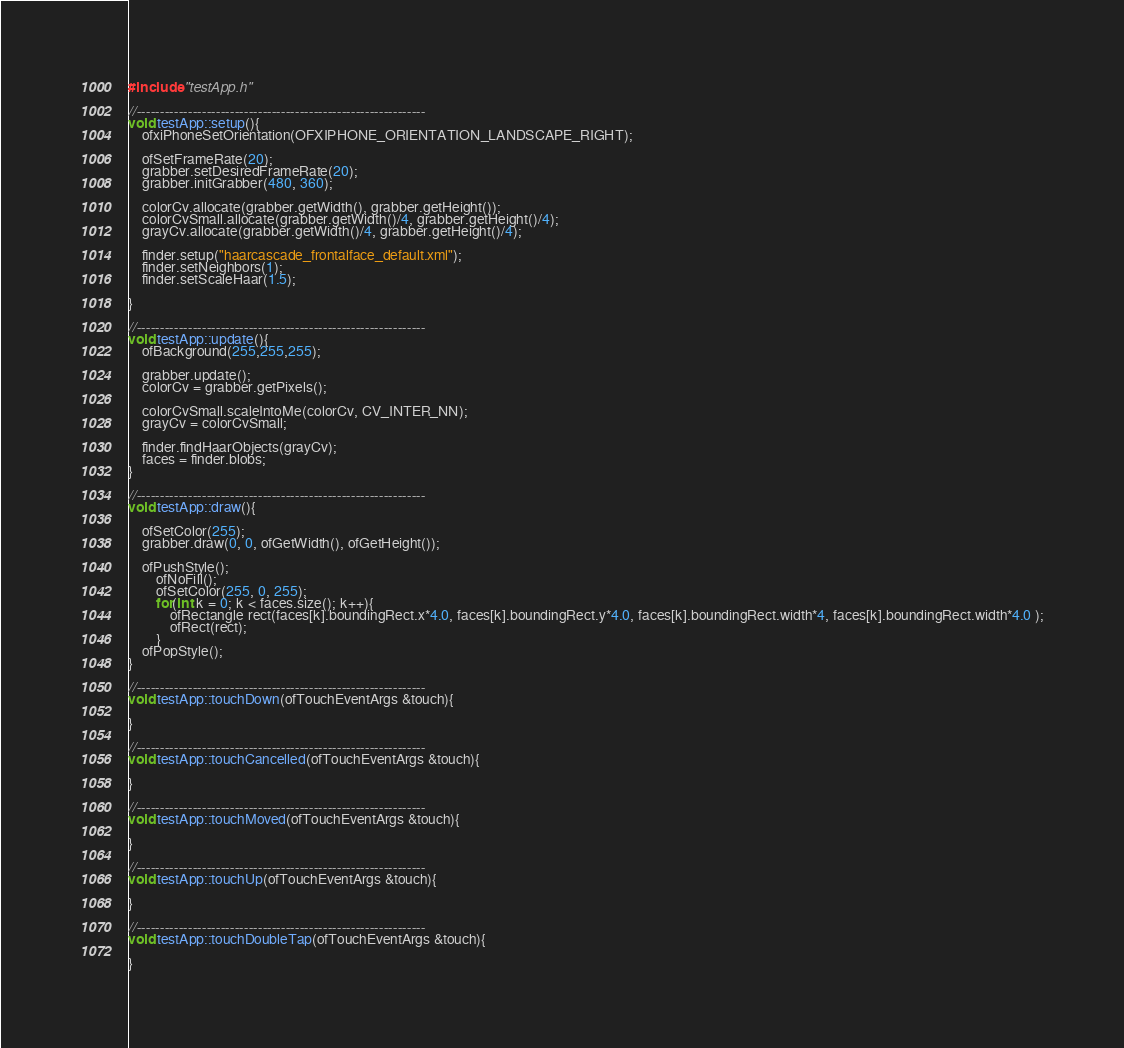<code> <loc_0><loc_0><loc_500><loc_500><_ObjectiveC_>#include "testApp.h"

//--------------------------------------------------------------
void testApp::setup(){	
	ofxiPhoneSetOrientation(OFXIPHONE_ORIENTATION_LANDSCAPE_RIGHT);

	ofSetFrameRate(20);
	grabber.setDesiredFrameRate(20);
	grabber.initGrabber(480, 360);
	
	colorCv.allocate(grabber.getWidth(), grabber.getHeight());
	colorCvSmall.allocate(grabber.getWidth()/4, grabber.getHeight()/4);
	grayCv.allocate(grabber.getWidth()/4, grabber.getHeight()/4);

	finder.setup("haarcascade_frontalface_default.xml");
	finder.setNeighbors(1);
	finder.setScaleHaar(1.5);
	
}

//--------------------------------------------------------------
void testApp::update(){
	ofBackground(255,255,255);	
	
	grabber.update();
	colorCv = grabber.getPixels();
	
	colorCvSmall.scaleIntoMe(colorCv, CV_INTER_NN);
	grayCv = colorCvSmall;

	finder.findHaarObjects(grayCv);	
	faces = finder.blobs;
}

//--------------------------------------------------------------
void testApp::draw(){	
	
	ofSetColor(255);
	grabber.draw(0, 0, ofGetWidth(), ofGetHeight());
	
	ofPushStyle();
		ofNoFill();
		ofSetColor(255, 0, 255);
		for(int k = 0; k < faces.size(); k++){
			ofRectangle rect(faces[k].boundingRect.x*4.0, faces[k].boundingRect.y*4.0, faces[k].boundingRect.width*4, faces[k].boundingRect.width*4.0 );
			ofRect(rect);
		}
	ofPopStyle();
}

//--------------------------------------------------------------
void testApp::touchDown(ofTouchEventArgs &touch){

}

//--------------------------------------------------------------
void testApp::touchCancelled(ofTouchEventArgs &touch){

}

//--------------------------------------------------------------
void testApp::touchMoved(ofTouchEventArgs &touch){

}

//--------------------------------------------------------------
void testApp::touchUp(ofTouchEventArgs &touch){

}

//--------------------------------------------------------------
void testApp::touchDoubleTap(ofTouchEventArgs &touch){

}
</code> 